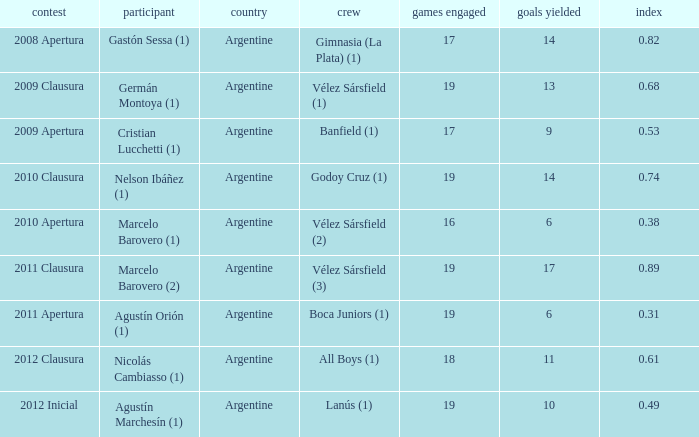What is the nationality of the 2012 clausura  tournament? Argentine. 